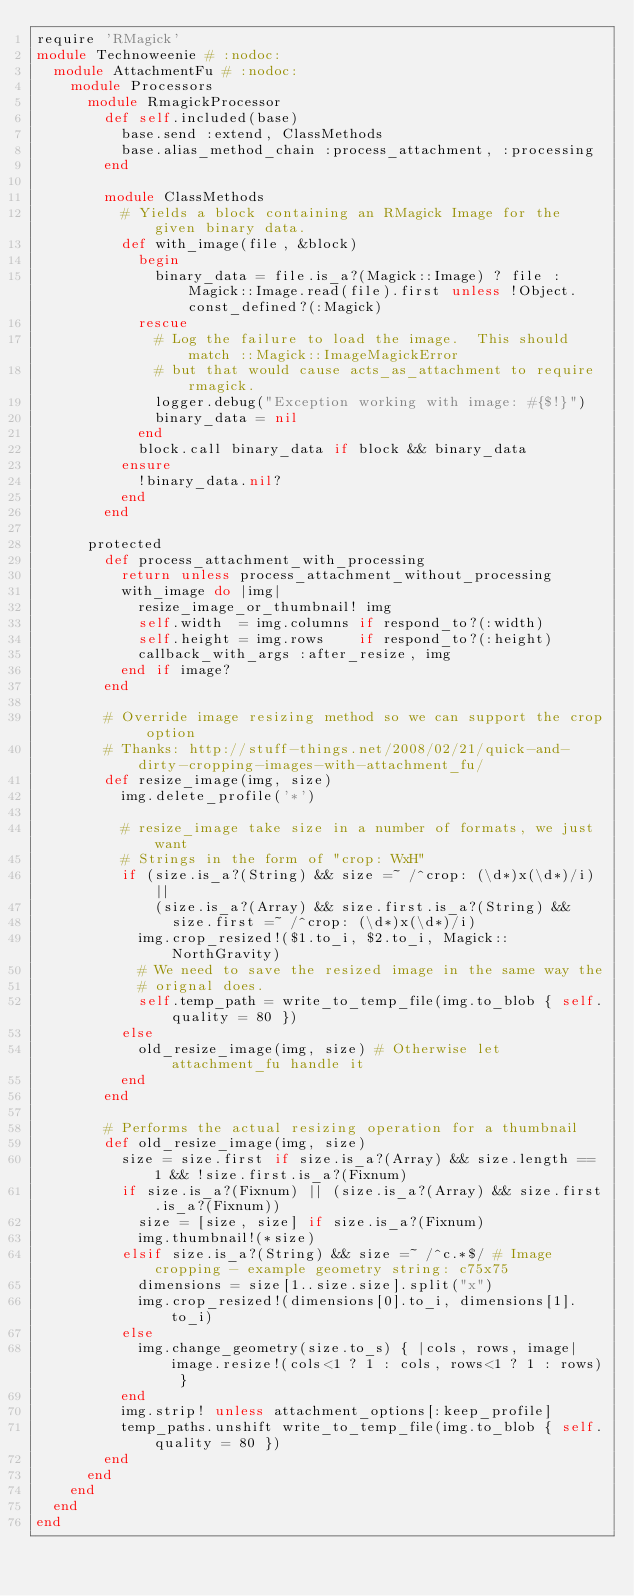Convert code to text. <code><loc_0><loc_0><loc_500><loc_500><_Ruby_>require 'RMagick'
module Technoweenie # :nodoc:
  module AttachmentFu # :nodoc:
    module Processors
      module RmagickProcessor
        def self.included(base)
          base.send :extend, ClassMethods
          base.alias_method_chain :process_attachment, :processing
        end

        module ClassMethods
          # Yields a block containing an RMagick Image for the given binary data.
          def with_image(file, &block)
            begin
              binary_data = file.is_a?(Magick::Image) ? file : Magick::Image.read(file).first unless !Object.const_defined?(:Magick)
            rescue
              # Log the failure to load the image.  This should match ::Magick::ImageMagickError
              # but that would cause acts_as_attachment to require rmagick.
              logger.debug("Exception working with image: #{$!}")
              binary_data = nil
            end
            block.call binary_data if block && binary_data
          ensure
            !binary_data.nil?
          end
        end

      protected
        def process_attachment_with_processing
          return unless process_attachment_without_processing
          with_image do |img|
            resize_image_or_thumbnail! img
            self.width  = img.columns if respond_to?(:width)
            self.height = img.rows    if respond_to?(:height)
            callback_with_args :after_resize, img
          end if image?
        end

        # Override image resizing method so we can support the crop option
        # Thanks: http://stuff-things.net/2008/02/21/quick-and-dirty-cropping-images-with-attachment_fu/
        def resize_image(img, size)
          img.delete_profile('*')
          
          # resize_image take size in a number of formats, we just want
          # Strings in the form of "crop: WxH"
          if (size.is_a?(String) && size =~ /^crop: (\d*)x(\d*)/i) ||
              (size.is_a?(Array) && size.first.is_a?(String) &&
                size.first =~ /^crop: (\d*)x(\d*)/i)
            img.crop_resized!($1.to_i, $2.to_i, Magick::NorthGravity)
            # We need to save the resized image in the same way the
            # orignal does.
            self.temp_path = write_to_temp_file(img.to_blob { self.quality = 80 })
          else
            old_resize_image(img, size) # Otherwise let attachment_fu handle it
          end
        end

        # Performs the actual resizing operation for a thumbnail
        def old_resize_image(img, size)
          size = size.first if size.is_a?(Array) && size.length == 1 && !size.first.is_a?(Fixnum)
          if size.is_a?(Fixnum) || (size.is_a?(Array) && size.first.is_a?(Fixnum))
            size = [size, size] if size.is_a?(Fixnum)
            img.thumbnail!(*size)
          elsif size.is_a?(String) && size =~ /^c.*$/ # Image cropping - example geometry string: c75x75
            dimensions = size[1..size.size].split("x")
            img.crop_resized!(dimensions[0].to_i, dimensions[1].to_i)
          else
            img.change_geometry(size.to_s) { |cols, rows, image| image.resize!(cols<1 ? 1 : cols, rows<1 ? 1 : rows) }
          end
          img.strip! unless attachment_options[:keep_profile]
          temp_paths.unshift write_to_temp_file(img.to_blob { self.quality = 80 })
        end
      end
    end
  end
end
</code> 